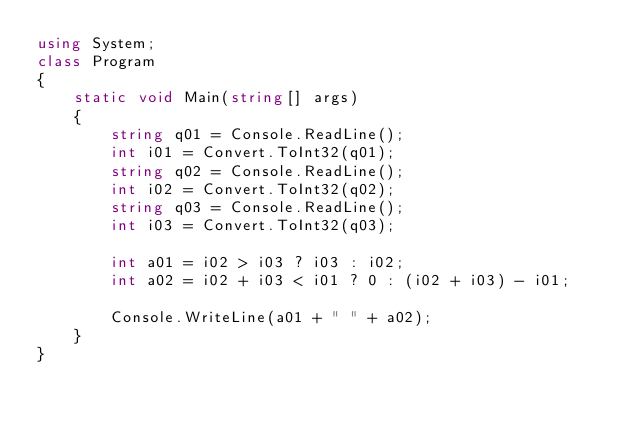<code> <loc_0><loc_0><loc_500><loc_500><_C#_>using System;
class Program
{
    static void Main(string[] args)
    {
        string q01 = Console.ReadLine();
        int i01 = Convert.ToInt32(q01);
        string q02 = Console.ReadLine();
        int i02 = Convert.ToInt32(q02);
        string q03 = Console.ReadLine();
        int i03 = Convert.ToInt32(q03);

        int a01 = i02 > i03 ? i03 : i02;
        int a02 = i02 + i03 < i01 ? 0 : (i02 + i03) - i01;

        Console.WriteLine(a01 + " " + a02);
    }
}</code> 